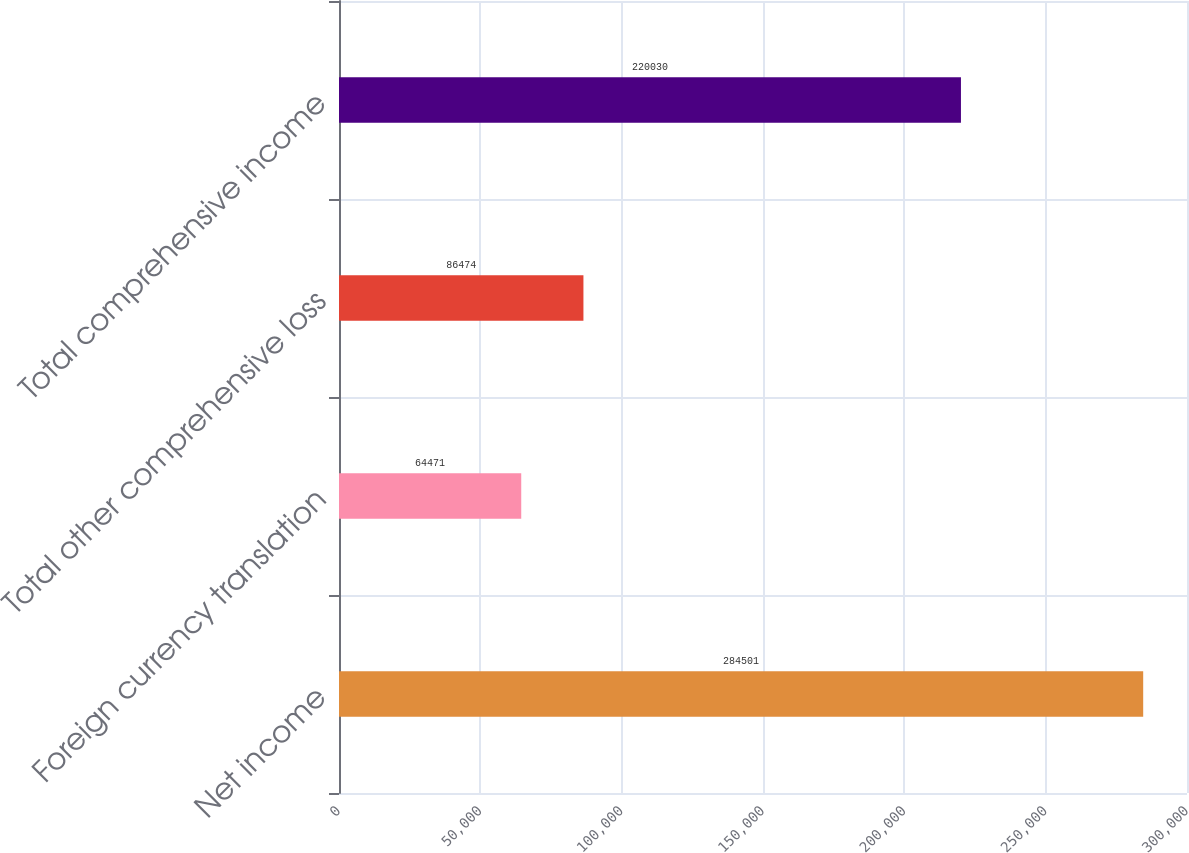<chart> <loc_0><loc_0><loc_500><loc_500><bar_chart><fcel>Net income<fcel>Foreign currency translation<fcel>Total other comprehensive loss<fcel>Total comprehensive income<nl><fcel>284501<fcel>64471<fcel>86474<fcel>220030<nl></chart> 